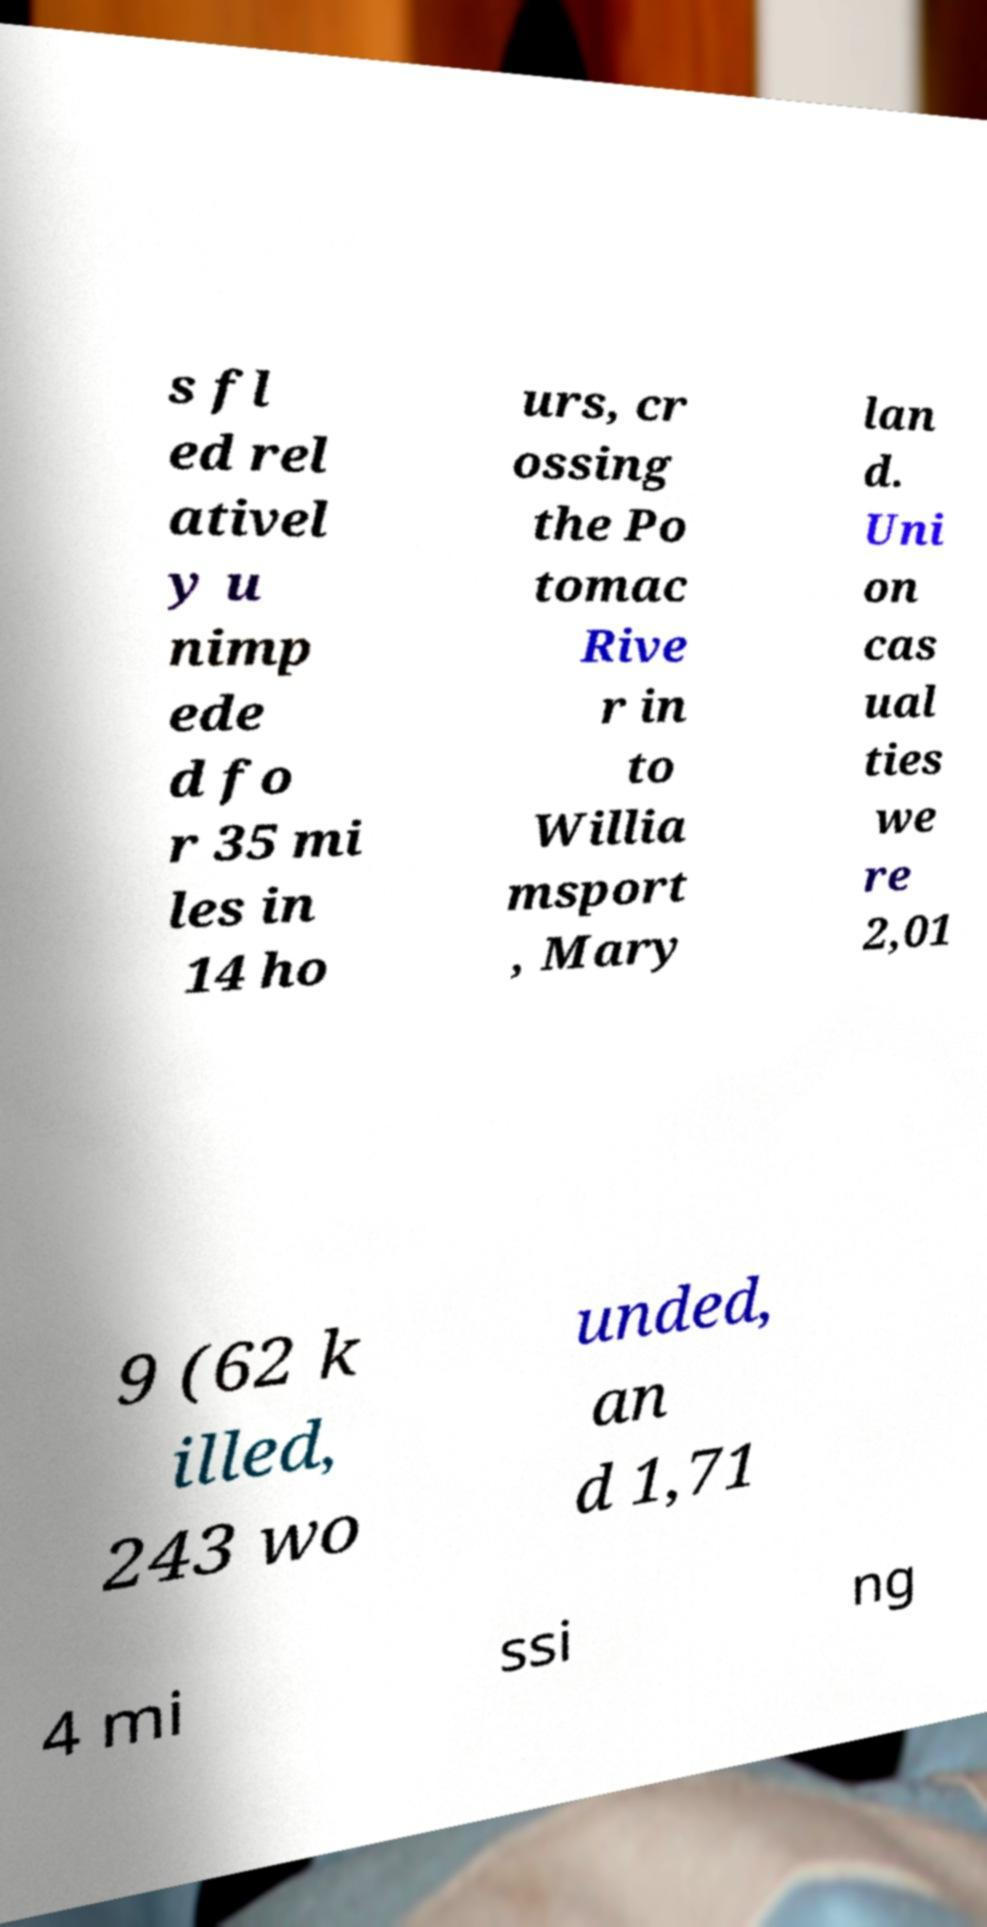Could you assist in decoding the text presented in this image and type it out clearly? s fl ed rel ativel y u nimp ede d fo r 35 mi les in 14 ho urs, cr ossing the Po tomac Rive r in to Willia msport , Mary lan d. Uni on cas ual ties we re 2,01 9 (62 k illed, 243 wo unded, an d 1,71 4 mi ssi ng 